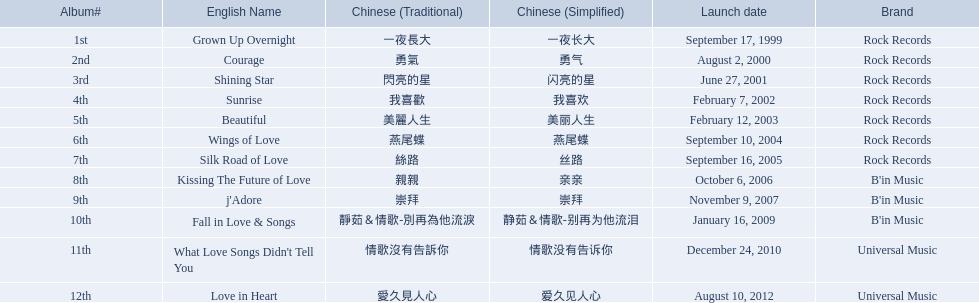What were the albums? Grown Up Overnight, Courage, Shining Star, Sunrise, Beautiful, Wings of Love, Silk Road of Love, Kissing The Future of Love, j'Adore, Fall in Love & Songs, What Love Songs Didn't Tell You, Love in Heart. Which ones were released by b'in music? Kissing The Future of Love, j'Adore. Of these, which one was in an even-numbered year? Kissing The Future of Love. 